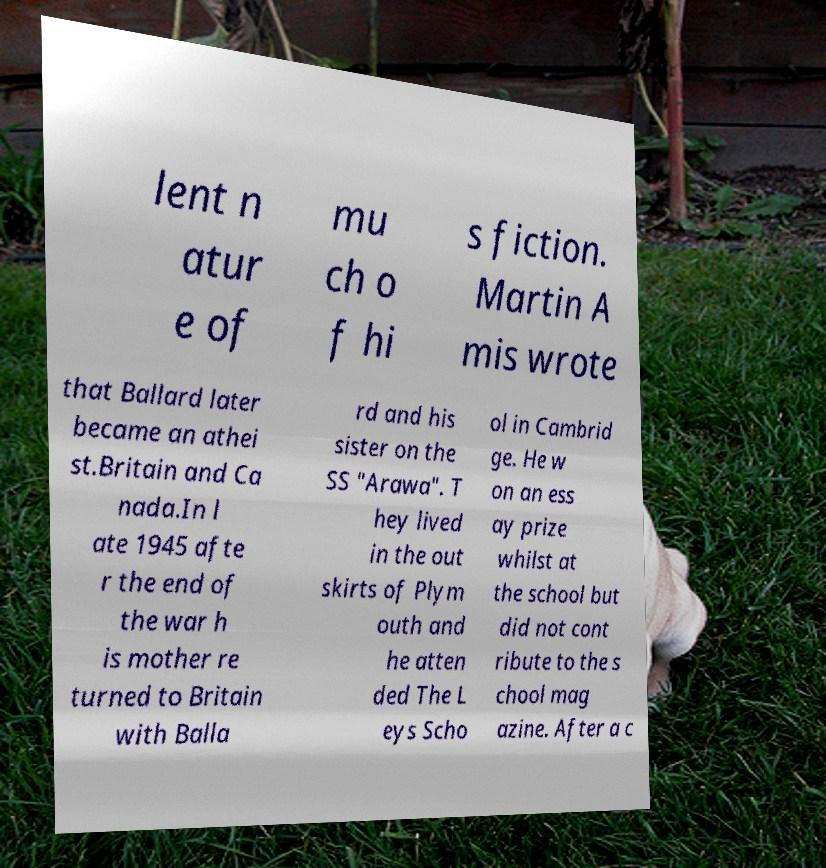For documentation purposes, I need the text within this image transcribed. Could you provide that? lent n atur e of mu ch o f hi s fiction. Martin A mis wrote that Ballard later became an athei st.Britain and Ca nada.In l ate 1945 afte r the end of the war h is mother re turned to Britain with Balla rd and his sister on the SS "Arawa". T hey lived in the out skirts of Plym outh and he atten ded The L eys Scho ol in Cambrid ge. He w on an ess ay prize whilst at the school but did not cont ribute to the s chool mag azine. After a c 